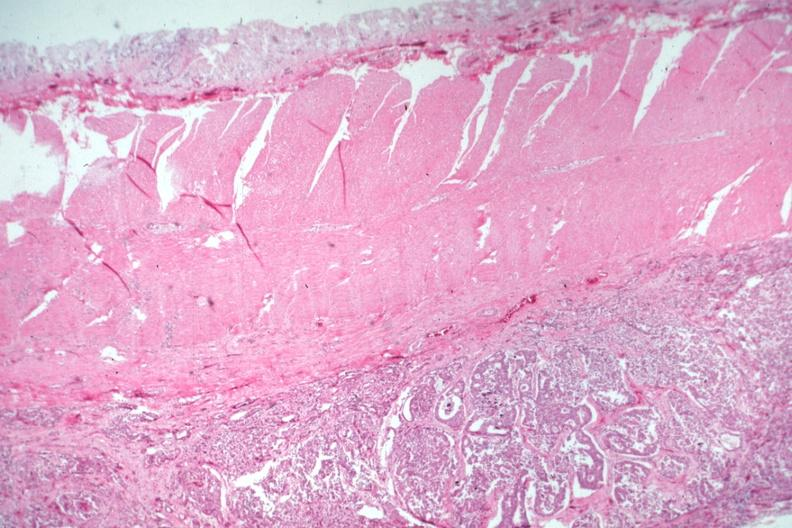s glomerulosa present?
Answer the question using a single word or phrase. No 